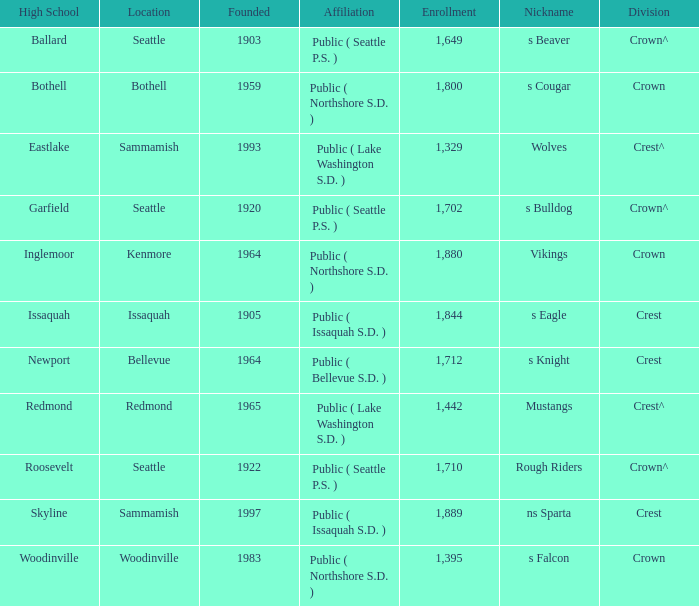What is the connection of a high school in issaquah founded prior to 1965? Public ( Issaquah S.D. ). 